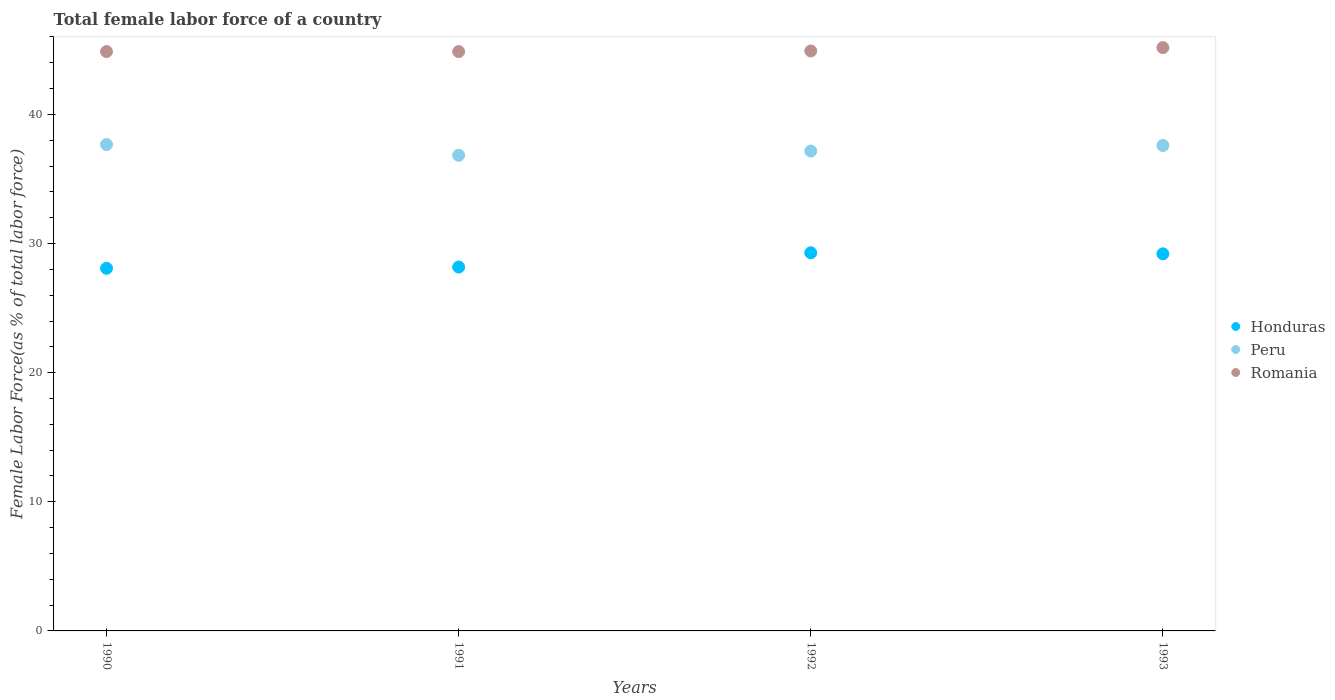How many different coloured dotlines are there?
Your answer should be compact. 3. Is the number of dotlines equal to the number of legend labels?
Make the answer very short. Yes. What is the percentage of female labor force in Peru in 1991?
Ensure brevity in your answer.  36.84. Across all years, what is the maximum percentage of female labor force in Peru?
Ensure brevity in your answer.  37.67. Across all years, what is the minimum percentage of female labor force in Honduras?
Make the answer very short. 28.09. In which year was the percentage of female labor force in Peru maximum?
Offer a terse response. 1990. What is the total percentage of female labor force in Romania in the graph?
Provide a short and direct response. 179.83. What is the difference between the percentage of female labor force in Peru in 1991 and that in 1993?
Your answer should be compact. -0.76. What is the difference between the percentage of female labor force in Romania in 1991 and the percentage of female labor force in Peru in 1992?
Offer a very short reply. 7.7. What is the average percentage of female labor force in Romania per year?
Your answer should be very brief. 44.96. In the year 1991, what is the difference between the percentage of female labor force in Peru and percentage of female labor force in Honduras?
Your answer should be compact. 8.66. What is the ratio of the percentage of female labor force in Peru in 1990 to that in 1992?
Keep it short and to the point. 1.01. Is the percentage of female labor force in Romania in 1990 less than that in 1992?
Offer a terse response. Yes. What is the difference between the highest and the second highest percentage of female labor force in Peru?
Your answer should be very brief. 0.07. What is the difference between the highest and the lowest percentage of female labor force in Romania?
Your answer should be compact. 0.31. In how many years, is the percentage of female labor force in Peru greater than the average percentage of female labor force in Peru taken over all years?
Offer a very short reply. 2. Is it the case that in every year, the sum of the percentage of female labor force in Honduras and percentage of female labor force in Romania  is greater than the percentage of female labor force in Peru?
Your answer should be very brief. Yes. How many dotlines are there?
Ensure brevity in your answer.  3. Does the graph contain any zero values?
Ensure brevity in your answer.  No. Where does the legend appear in the graph?
Provide a succinct answer. Center right. What is the title of the graph?
Your answer should be very brief. Total female labor force of a country. Does "Croatia" appear as one of the legend labels in the graph?
Offer a very short reply. No. What is the label or title of the X-axis?
Make the answer very short. Years. What is the label or title of the Y-axis?
Offer a terse response. Female Labor Force(as % of total labor force). What is the Female Labor Force(as % of total labor force) in Honduras in 1990?
Your answer should be compact. 28.09. What is the Female Labor Force(as % of total labor force) of Peru in 1990?
Ensure brevity in your answer.  37.67. What is the Female Labor Force(as % of total labor force) of Romania in 1990?
Offer a terse response. 44.87. What is the Female Labor Force(as % of total labor force) of Honduras in 1991?
Make the answer very short. 28.18. What is the Female Labor Force(as % of total labor force) in Peru in 1991?
Offer a terse response. 36.84. What is the Female Labor Force(as % of total labor force) in Romania in 1991?
Make the answer very short. 44.87. What is the Female Labor Force(as % of total labor force) of Honduras in 1992?
Give a very brief answer. 29.29. What is the Female Labor Force(as % of total labor force) of Peru in 1992?
Your answer should be very brief. 37.16. What is the Female Labor Force(as % of total labor force) in Romania in 1992?
Offer a terse response. 44.92. What is the Female Labor Force(as % of total labor force) of Honduras in 1993?
Your response must be concise. 29.2. What is the Female Labor Force(as % of total labor force) of Peru in 1993?
Offer a very short reply. 37.59. What is the Female Labor Force(as % of total labor force) in Romania in 1993?
Give a very brief answer. 45.18. Across all years, what is the maximum Female Labor Force(as % of total labor force) of Honduras?
Give a very brief answer. 29.29. Across all years, what is the maximum Female Labor Force(as % of total labor force) in Peru?
Your response must be concise. 37.67. Across all years, what is the maximum Female Labor Force(as % of total labor force) of Romania?
Make the answer very short. 45.18. Across all years, what is the minimum Female Labor Force(as % of total labor force) in Honduras?
Provide a succinct answer. 28.09. Across all years, what is the minimum Female Labor Force(as % of total labor force) of Peru?
Offer a terse response. 36.84. Across all years, what is the minimum Female Labor Force(as % of total labor force) of Romania?
Your answer should be compact. 44.87. What is the total Female Labor Force(as % of total labor force) in Honduras in the graph?
Offer a very short reply. 114.76. What is the total Female Labor Force(as % of total labor force) in Peru in the graph?
Provide a succinct answer. 149.26. What is the total Female Labor Force(as % of total labor force) in Romania in the graph?
Your answer should be very brief. 179.83. What is the difference between the Female Labor Force(as % of total labor force) in Honduras in 1990 and that in 1991?
Ensure brevity in your answer.  -0.09. What is the difference between the Female Labor Force(as % of total labor force) in Peru in 1990 and that in 1991?
Offer a very short reply. 0.83. What is the difference between the Female Labor Force(as % of total labor force) in Romania in 1990 and that in 1991?
Keep it short and to the point. 0. What is the difference between the Female Labor Force(as % of total labor force) in Honduras in 1990 and that in 1992?
Offer a very short reply. -1.2. What is the difference between the Female Labor Force(as % of total labor force) in Peru in 1990 and that in 1992?
Provide a succinct answer. 0.5. What is the difference between the Female Labor Force(as % of total labor force) of Romania in 1990 and that in 1992?
Offer a very short reply. -0.04. What is the difference between the Female Labor Force(as % of total labor force) of Honduras in 1990 and that in 1993?
Offer a terse response. -1.12. What is the difference between the Female Labor Force(as % of total labor force) of Peru in 1990 and that in 1993?
Offer a terse response. 0.07. What is the difference between the Female Labor Force(as % of total labor force) in Romania in 1990 and that in 1993?
Give a very brief answer. -0.3. What is the difference between the Female Labor Force(as % of total labor force) in Honduras in 1991 and that in 1992?
Provide a succinct answer. -1.11. What is the difference between the Female Labor Force(as % of total labor force) of Peru in 1991 and that in 1992?
Ensure brevity in your answer.  -0.33. What is the difference between the Female Labor Force(as % of total labor force) in Romania in 1991 and that in 1992?
Your answer should be very brief. -0.05. What is the difference between the Female Labor Force(as % of total labor force) of Honduras in 1991 and that in 1993?
Your answer should be compact. -1.02. What is the difference between the Female Labor Force(as % of total labor force) in Peru in 1991 and that in 1993?
Provide a short and direct response. -0.76. What is the difference between the Female Labor Force(as % of total labor force) in Romania in 1991 and that in 1993?
Ensure brevity in your answer.  -0.31. What is the difference between the Female Labor Force(as % of total labor force) in Honduras in 1992 and that in 1993?
Keep it short and to the point. 0.08. What is the difference between the Female Labor Force(as % of total labor force) of Peru in 1992 and that in 1993?
Offer a terse response. -0.43. What is the difference between the Female Labor Force(as % of total labor force) in Romania in 1992 and that in 1993?
Your answer should be very brief. -0.26. What is the difference between the Female Labor Force(as % of total labor force) in Honduras in 1990 and the Female Labor Force(as % of total labor force) in Peru in 1991?
Make the answer very short. -8.75. What is the difference between the Female Labor Force(as % of total labor force) in Honduras in 1990 and the Female Labor Force(as % of total labor force) in Romania in 1991?
Provide a succinct answer. -16.78. What is the difference between the Female Labor Force(as % of total labor force) in Peru in 1990 and the Female Labor Force(as % of total labor force) in Romania in 1991?
Offer a terse response. -7.2. What is the difference between the Female Labor Force(as % of total labor force) in Honduras in 1990 and the Female Labor Force(as % of total labor force) in Peru in 1992?
Offer a terse response. -9.08. What is the difference between the Female Labor Force(as % of total labor force) of Honduras in 1990 and the Female Labor Force(as % of total labor force) of Romania in 1992?
Provide a short and direct response. -16.83. What is the difference between the Female Labor Force(as % of total labor force) of Peru in 1990 and the Female Labor Force(as % of total labor force) of Romania in 1992?
Your answer should be compact. -7.25. What is the difference between the Female Labor Force(as % of total labor force) of Honduras in 1990 and the Female Labor Force(as % of total labor force) of Peru in 1993?
Give a very brief answer. -9.51. What is the difference between the Female Labor Force(as % of total labor force) in Honduras in 1990 and the Female Labor Force(as % of total labor force) in Romania in 1993?
Your answer should be very brief. -17.09. What is the difference between the Female Labor Force(as % of total labor force) in Peru in 1990 and the Female Labor Force(as % of total labor force) in Romania in 1993?
Provide a short and direct response. -7.51. What is the difference between the Female Labor Force(as % of total labor force) in Honduras in 1991 and the Female Labor Force(as % of total labor force) in Peru in 1992?
Your answer should be very brief. -8.99. What is the difference between the Female Labor Force(as % of total labor force) of Honduras in 1991 and the Female Labor Force(as % of total labor force) of Romania in 1992?
Ensure brevity in your answer.  -16.74. What is the difference between the Female Labor Force(as % of total labor force) in Peru in 1991 and the Female Labor Force(as % of total labor force) in Romania in 1992?
Provide a short and direct response. -8.08. What is the difference between the Female Labor Force(as % of total labor force) in Honduras in 1991 and the Female Labor Force(as % of total labor force) in Peru in 1993?
Give a very brief answer. -9.41. What is the difference between the Female Labor Force(as % of total labor force) of Honduras in 1991 and the Female Labor Force(as % of total labor force) of Romania in 1993?
Make the answer very short. -17. What is the difference between the Female Labor Force(as % of total labor force) of Peru in 1991 and the Female Labor Force(as % of total labor force) of Romania in 1993?
Offer a terse response. -8.34. What is the difference between the Female Labor Force(as % of total labor force) of Honduras in 1992 and the Female Labor Force(as % of total labor force) of Peru in 1993?
Your response must be concise. -8.31. What is the difference between the Female Labor Force(as % of total labor force) of Honduras in 1992 and the Female Labor Force(as % of total labor force) of Romania in 1993?
Your response must be concise. -15.89. What is the difference between the Female Labor Force(as % of total labor force) in Peru in 1992 and the Female Labor Force(as % of total labor force) in Romania in 1993?
Provide a succinct answer. -8.01. What is the average Female Labor Force(as % of total labor force) of Honduras per year?
Give a very brief answer. 28.69. What is the average Female Labor Force(as % of total labor force) in Peru per year?
Give a very brief answer. 37.32. What is the average Female Labor Force(as % of total labor force) of Romania per year?
Provide a short and direct response. 44.96. In the year 1990, what is the difference between the Female Labor Force(as % of total labor force) of Honduras and Female Labor Force(as % of total labor force) of Peru?
Offer a terse response. -9.58. In the year 1990, what is the difference between the Female Labor Force(as % of total labor force) of Honduras and Female Labor Force(as % of total labor force) of Romania?
Your answer should be very brief. -16.79. In the year 1990, what is the difference between the Female Labor Force(as % of total labor force) in Peru and Female Labor Force(as % of total labor force) in Romania?
Offer a terse response. -7.21. In the year 1991, what is the difference between the Female Labor Force(as % of total labor force) of Honduras and Female Labor Force(as % of total labor force) of Peru?
Your response must be concise. -8.66. In the year 1991, what is the difference between the Female Labor Force(as % of total labor force) of Honduras and Female Labor Force(as % of total labor force) of Romania?
Keep it short and to the point. -16.69. In the year 1991, what is the difference between the Female Labor Force(as % of total labor force) of Peru and Female Labor Force(as % of total labor force) of Romania?
Your answer should be very brief. -8.03. In the year 1992, what is the difference between the Female Labor Force(as % of total labor force) of Honduras and Female Labor Force(as % of total labor force) of Peru?
Make the answer very short. -7.88. In the year 1992, what is the difference between the Female Labor Force(as % of total labor force) of Honduras and Female Labor Force(as % of total labor force) of Romania?
Ensure brevity in your answer.  -15.63. In the year 1992, what is the difference between the Female Labor Force(as % of total labor force) of Peru and Female Labor Force(as % of total labor force) of Romania?
Provide a succinct answer. -7.75. In the year 1993, what is the difference between the Female Labor Force(as % of total labor force) in Honduras and Female Labor Force(as % of total labor force) in Peru?
Give a very brief answer. -8.39. In the year 1993, what is the difference between the Female Labor Force(as % of total labor force) of Honduras and Female Labor Force(as % of total labor force) of Romania?
Provide a succinct answer. -15.97. In the year 1993, what is the difference between the Female Labor Force(as % of total labor force) of Peru and Female Labor Force(as % of total labor force) of Romania?
Your response must be concise. -7.58. What is the ratio of the Female Labor Force(as % of total labor force) in Honduras in 1990 to that in 1991?
Provide a short and direct response. 1. What is the ratio of the Female Labor Force(as % of total labor force) of Peru in 1990 to that in 1991?
Ensure brevity in your answer.  1.02. What is the ratio of the Female Labor Force(as % of total labor force) in Romania in 1990 to that in 1991?
Your response must be concise. 1. What is the ratio of the Female Labor Force(as % of total labor force) in Peru in 1990 to that in 1992?
Provide a short and direct response. 1.01. What is the ratio of the Female Labor Force(as % of total labor force) in Romania in 1990 to that in 1992?
Keep it short and to the point. 1. What is the ratio of the Female Labor Force(as % of total labor force) of Honduras in 1990 to that in 1993?
Make the answer very short. 0.96. What is the ratio of the Female Labor Force(as % of total labor force) of Peru in 1990 to that in 1993?
Provide a succinct answer. 1. What is the ratio of the Female Labor Force(as % of total labor force) of Romania in 1990 to that in 1993?
Offer a terse response. 0.99. What is the ratio of the Female Labor Force(as % of total labor force) of Honduras in 1991 to that in 1992?
Your answer should be very brief. 0.96. What is the ratio of the Female Labor Force(as % of total labor force) in Peru in 1991 to that in 1992?
Make the answer very short. 0.99. What is the ratio of the Female Labor Force(as % of total labor force) of Honduras in 1991 to that in 1993?
Offer a terse response. 0.96. What is the ratio of the Female Labor Force(as % of total labor force) in Peru in 1991 to that in 1993?
Your response must be concise. 0.98. What is the ratio of the Female Labor Force(as % of total labor force) in Romania in 1991 to that in 1993?
Provide a short and direct response. 0.99. What is the ratio of the Female Labor Force(as % of total labor force) of Romania in 1992 to that in 1993?
Your response must be concise. 0.99. What is the difference between the highest and the second highest Female Labor Force(as % of total labor force) of Honduras?
Provide a short and direct response. 0.08. What is the difference between the highest and the second highest Female Labor Force(as % of total labor force) of Peru?
Your answer should be compact. 0.07. What is the difference between the highest and the second highest Female Labor Force(as % of total labor force) in Romania?
Ensure brevity in your answer.  0.26. What is the difference between the highest and the lowest Female Labor Force(as % of total labor force) in Honduras?
Provide a succinct answer. 1.2. What is the difference between the highest and the lowest Female Labor Force(as % of total labor force) in Peru?
Provide a succinct answer. 0.83. What is the difference between the highest and the lowest Female Labor Force(as % of total labor force) in Romania?
Your response must be concise. 0.31. 